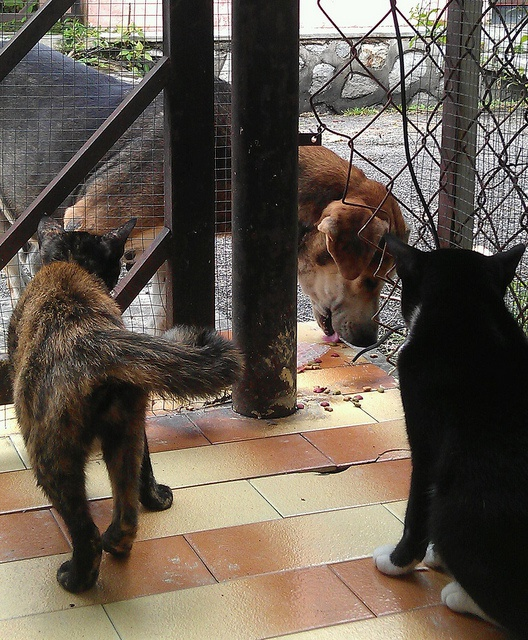Describe the objects in this image and their specific colors. I can see cat in black, gray, and maroon tones, cat in black, gray, and darkgray tones, and dog in black, gray, and maroon tones in this image. 